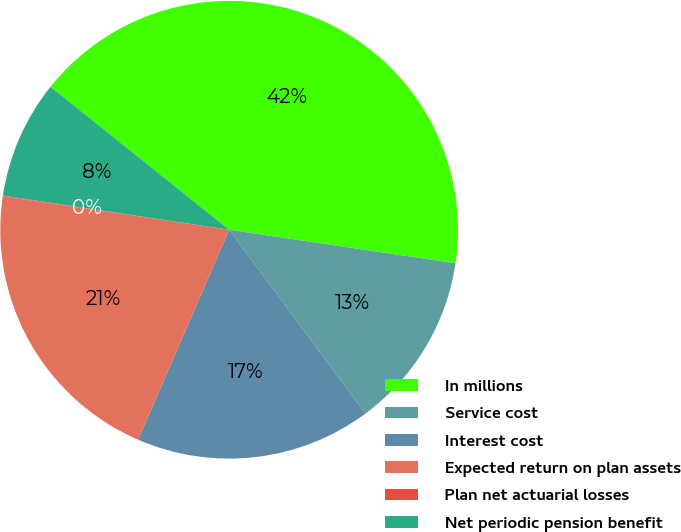Convert chart. <chart><loc_0><loc_0><loc_500><loc_500><pie_chart><fcel>In millions<fcel>Service cost<fcel>Interest cost<fcel>Expected return on plan assets<fcel>Plan net actuarial losses<fcel>Net periodic pension benefit<nl><fcel>41.6%<fcel>12.51%<fcel>16.67%<fcel>20.82%<fcel>0.05%<fcel>8.36%<nl></chart> 